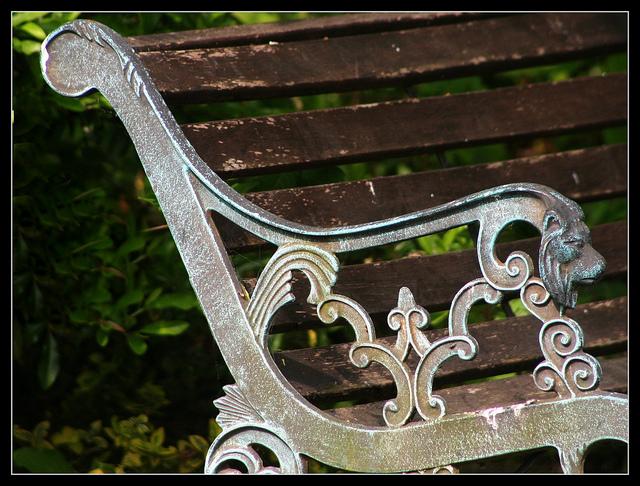What is the pattern type on the bench called?
Answer briefly. Lion. What kind of bush is that?
Concise answer only. Green. Is the whole bench made from all one material?
Concise answer only. No. What colors are the bench?
Answer briefly. Brown. 